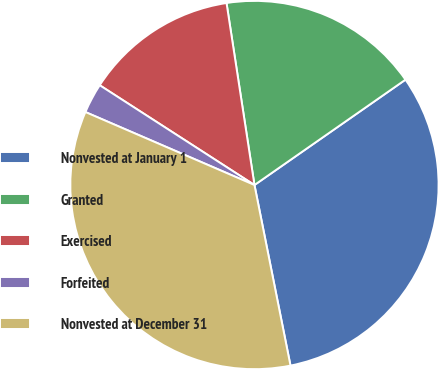<chart> <loc_0><loc_0><loc_500><loc_500><pie_chart><fcel>Nonvested at January 1<fcel>Granted<fcel>Exercised<fcel>Forfeited<fcel>Nonvested at December 31<nl><fcel>31.56%<fcel>17.73%<fcel>13.46%<fcel>2.63%<fcel>34.62%<nl></chart> 